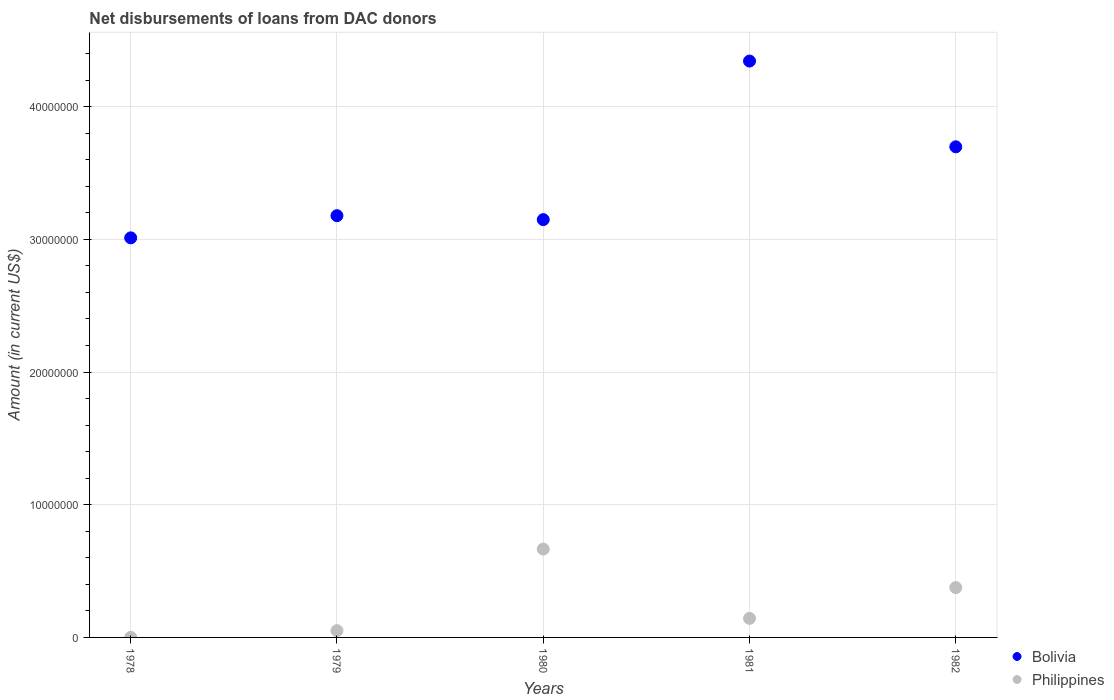How many different coloured dotlines are there?
Offer a terse response. 2. What is the amount of loans disbursed in Philippines in 1982?
Offer a very short reply. 3.76e+06. Across all years, what is the maximum amount of loans disbursed in Philippines?
Your answer should be compact. 6.66e+06. Across all years, what is the minimum amount of loans disbursed in Bolivia?
Your answer should be compact. 3.01e+07. In which year was the amount of loans disbursed in Bolivia minimum?
Ensure brevity in your answer.  1978. What is the total amount of loans disbursed in Bolivia in the graph?
Give a very brief answer. 1.74e+08. What is the difference between the amount of loans disbursed in Philippines in 1979 and that in 1980?
Give a very brief answer. -6.15e+06. What is the difference between the amount of loans disbursed in Philippines in 1978 and the amount of loans disbursed in Bolivia in 1980?
Your response must be concise. -3.15e+07. What is the average amount of loans disbursed in Philippines per year?
Your response must be concise. 2.47e+06. In the year 1982, what is the difference between the amount of loans disbursed in Philippines and amount of loans disbursed in Bolivia?
Provide a succinct answer. -3.32e+07. In how many years, is the amount of loans disbursed in Philippines greater than 32000000 US$?
Keep it short and to the point. 0. What is the ratio of the amount of loans disbursed in Philippines in 1978 to that in 1980?
Give a very brief answer. 0. Is the amount of loans disbursed in Philippines in 1980 less than that in 1982?
Your answer should be very brief. No. Is the difference between the amount of loans disbursed in Philippines in 1978 and 1982 greater than the difference between the amount of loans disbursed in Bolivia in 1978 and 1982?
Offer a terse response. Yes. What is the difference between the highest and the second highest amount of loans disbursed in Philippines?
Give a very brief answer. 2.90e+06. What is the difference between the highest and the lowest amount of loans disbursed in Philippines?
Keep it short and to the point. 6.65e+06. In how many years, is the amount of loans disbursed in Philippines greater than the average amount of loans disbursed in Philippines taken over all years?
Offer a terse response. 2. What is the difference between two consecutive major ticks on the Y-axis?
Provide a short and direct response. 1.00e+07. Does the graph contain any zero values?
Keep it short and to the point. No. Where does the legend appear in the graph?
Offer a very short reply. Bottom right. How are the legend labels stacked?
Your answer should be compact. Vertical. What is the title of the graph?
Provide a short and direct response. Net disbursements of loans from DAC donors. Does "Macao" appear as one of the legend labels in the graph?
Provide a succinct answer. No. What is the Amount (in current US$) of Bolivia in 1978?
Offer a very short reply. 3.01e+07. What is the Amount (in current US$) in Philippines in 1978?
Ensure brevity in your answer.  8000. What is the Amount (in current US$) in Bolivia in 1979?
Your answer should be very brief. 3.18e+07. What is the Amount (in current US$) of Philippines in 1979?
Make the answer very short. 5.11e+05. What is the Amount (in current US$) in Bolivia in 1980?
Your answer should be very brief. 3.15e+07. What is the Amount (in current US$) of Philippines in 1980?
Your answer should be very brief. 6.66e+06. What is the Amount (in current US$) in Bolivia in 1981?
Give a very brief answer. 4.34e+07. What is the Amount (in current US$) in Philippines in 1981?
Provide a succinct answer. 1.44e+06. What is the Amount (in current US$) in Bolivia in 1982?
Your response must be concise. 3.70e+07. What is the Amount (in current US$) in Philippines in 1982?
Provide a succinct answer. 3.76e+06. Across all years, what is the maximum Amount (in current US$) of Bolivia?
Give a very brief answer. 4.34e+07. Across all years, what is the maximum Amount (in current US$) of Philippines?
Give a very brief answer. 6.66e+06. Across all years, what is the minimum Amount (in current US$) of Bolivia?
Ensure brevity in your answer.  3.01e+07. Across all years, what is the minimum Amount (in current US$) in Philippines?
Your response must be concise. 8000. What is the total Amount (in current US$) in Bolivia in the graph?
Offer a terse response. 1.74e+08. What is the total Amount (in current US$) of Philippines in the graph?
Your answer should be very brief. 1.24e+07. What is the difference between the Amount (in current US$) of Bolivia in 1978 and that in 1979?
Provide a succinct answer. -1.67e+06. What is the difference between the Amount (in current US$) of Philippines in 1978 and that in 1979?
Your answer should be compact. -5.03e+05. What is the difference between the Amount (in current US$) of Bolivia in 1978 and that in 1980?
Your response must be concise. -1.37e+06. What is the difference between the Amount (in current US$) in Philippines in 1978 and that in 1980?
Provide a short and direct response. -6.65e+06. What is the difference between the Amount (in current US$) of Bolivia in 1978 and that in 1981?
Make the answer very short. -1.33e+07. What is the difference between the Amount (in current US$) of Philippines in 1978 and that in 1981?
Give a very brief answer. -1.43e+06. What is the difference between the Amount (in current US$) of Bolivia in 1978 and that in 1982?
Provide a succinct answer. -6.86e+06. What is the difference between the Amount (in current US$) in Philippines in 1978 and that in 1982?
Provide a succinct answer. -3.75e+06. What is the difference between the Amount (in current US$) in Bolivia in 1979 and that in 1980?
Provide a short and direct response. 2.98e+05. What is the difference between the Amount (in current US$) in Philippines in 1979 and that in 1980?
Your response must be concise. -6.15e+06. What is the difference between the Amount (in current US$) of Bolivia in 1979 and that in 1981?
Ensure brevity in your answer.  -1.17e+07. What is the difference between the Amount (in current US$) in Philippines in 1979 and that in 1981?
Provide a short and direct response. -9.26e+05. What is the difference between the Amount (in current US$) in Bolivia in 1979 and that in 1982?
Offer a terse response. -5.19e+06. What is the difference between the Amount (in current US$) in Philippines in 1979 and that in 1982?
Give a very brief answer. -3.24e+06. What is the difference between the Amount (in current US$) in Bolivia in 1980 and that in 1981?
Your response must be concise. -1.20e+07. What is the difference between the Amount (in current US$) in Philippines in 1980 and that in 1981?
Your answer should be very brief. 5.22e+06. What is the difference between the Amount (in current US$) in Bolivia in 1980 and that in 1982?
Your answer should be very brief. -5.49e+06. What is the difference between the Amount (in current US$) in Philippines in 1980 and that in 1982?
Your answer should be compact. 2.90e+06. What is the difference between the Amount (in current US$) in Bolivia in 1981 and that in 1982?
Provide a succinct answer. 6.46e+06. What is the difference between the Amount (in current US$) of Philippines in 1981 and that in 1982?
Give a very brief answer. -2.32e+06. What is the difference between the Amount (in current US$) in Bolivia in 1978 and the Amount (in current US$) in Philippines in 1979?
Offer a terse response. 2.96e+07. What is the difference between the Amount (in current US$) in Bolivia in 1978 and the Amount (in current US$) in Philippines in 1980?
Your answer should be compact. 2.35e+07. What is the difference between the Amount (in current US$) of Bolivia in 1978 and the Amount (in current US$) of Philippines in 1981?
Keep it short and to the point. 2.87e+07. What is the difference between the Amount (in current US$) of Bolivia in 1978 and the Amount (in current US$) of Philippines in 1982?
Provide a succinct answer. 2.64e+07. What is the difference between the Amount (in current US$) of Bolivia in 1979 and the Amount (in current US$) of Philippines in 1980?
Offer a terse response. 2.51e+07. What is the difference between the Amount (in current US$) in Bolivia in 1979 and the Amount (in current US$) in Philippines in 1981?
Your answer should be very brief. 3.03e+07. What is the difference between the Amount (in current US$) in Bolivia in 1979 and the Amount (in current US$) in Philippines in 1982?
Make the answer very short. 2.80e+07. What is the difference between the Amount (in current US$) in Bolivia in 1980 and the Amount (in current US$) in Philippines in 1981?
Your response must be concise. 3.00e+07. What is the difference between the Amount (in current US$) in Bolivia in 1980 and the Amount (in current US$) in Philippines in 1982?
Ensure brevity in your answer.  2.77e+07. What is the difference between the Amount (in current US$) of Bolivia in 1981 and the Amount (in current US$) of Philippines in 1982?
Provide a succinct answer. 3.97e+07. What is the average Amount (in current US$) in Bolivia per year?
Offer a very short reply. 3.48e+07. What is the average Amount (in current US$) of Philippines per year?
Offer a terse response. 2.47e+06. In the year 1978, what is the difference between the Amount (in current US$) of Bolivia and Amount (in current US$) of Philippines?
Give a very brief answer. 3.01e+07. In the year 1979, what is the difference between the Amount (in current US$) in Bolivia and Amount (in current US$) in Philippines?
Provide a succinct answer. 3.13e+07. In the year 1980, what is the difference between the Amount (in current US$) of Bolivia and Amount (in current US$) of Philippines?
Keep it short and to the point. 2.48e+07. In the year 1981, what is the difference between the Amount (in current US$) of Bolivia and Amount (in current US$) of Philippines?
Ensure brevity in your answer.  4.20e+07. In the year 1982, what is the difference between the Amount (in current US$) in Bolivia and Amount (in current US$) in Philippines?
Offer a terse response. 3.32e+07. What is the ratio of the Amount (in current US$) in Philippines in 1978 to that in 1979?
Keep it short and to the point. 0.02. What is the ratio of the Amount (in current US$) of Bolivia in 1978 to that in 1980?
Offer a terse response. 0.96. What is the ratio of the Amount (in current US$) in Philippines in 1978 to that in 1980?
Give a very brief answer. 0. What is the ratio of the Amount (in current US$) in Bolivia in 1978 to that in 1981?
Keep it short and to the point. 0.69. What is the ratio of the Amount (in current US$) in Philippines in 1978 to that in 1981?
Your answer should be compact. 0.01. What is the ratio of the Amount (in current US$) of Bolivia in 1978 to that in 1982?
Give a very brief answer. 0.81. What is the ratio of the Amount (in current US$) of Philippines in 1978 to that in 1982?
Ensure brevity in your answer.  0. What is the ratio of the Amount (in current US$) in Bolivia in 1979 to that in 1980?
Ensure brevity in your answer.  1.01. What is the ratio of the Amount (in current US$) in Philippines in 1979 to that in 1980?
Make the answer very short. 0.08. What is the ratio of the Amount (in current US$) in Bolivia in 1979 to that in 1981?
Ensure brevity in your answer.  0.73. What is the ratio of the Amount (in current US$) in Philippines in 1979 to that in 1981?
Your answer should be very brief. 0.36. What is the ratio of the Amount (in current US$) in Bolivia in 1979 to that in 1982?
Provide a succinct answer. 0.86. What is the ratio of the Amount (in current US$) in Philippines in 1979 to that in 1982?
Offer a very short reply. 0.14. What is the ratio of the Amount (in current US$) in Bolivia in 1980 to that in 1981?
Your answer should be very brief. 0.72. What is the ratio of the Amount (in current US$) of Philippines in 1980 to that in 1981?
Make the answer very short. 4.63. What is the ratio of the Amount (in current US$) in Bolivia in 1980 to that in 1982?
Keep it short and to the point. 0.85. What is the ratio of the Amount (in current US$) of Philippines in 1980 to that in 1982?
Offer a very short reply. 1.77. What is the ratio of the Amount (in current US$) of Bolivia in 1981 to that in 1982?
Offer a very short reply. 1.17. What is the ratio of the Amount (in current US$) in Philippines in 1981 to that in 1982?
Ensure brevity in your answer.  0.38. What is the difference between the highest and the second highest Amount (in current US$) of Bolivia?
Provide a short and direct response. 6.46e+06. What is the difference between the highest and the second highest Amount (in current US$) of Philippines?
Provide a succinct answer. 2.90e+06. What is the difference between the highest and the lowest Amount (in current US$) of Bolivia?
Your answer should be compact. 1.33e+07. What is the difference between the highest and the lowest Amount (in current US$) in Philippines?
Provide a succinct answer. 6.65e+06. 